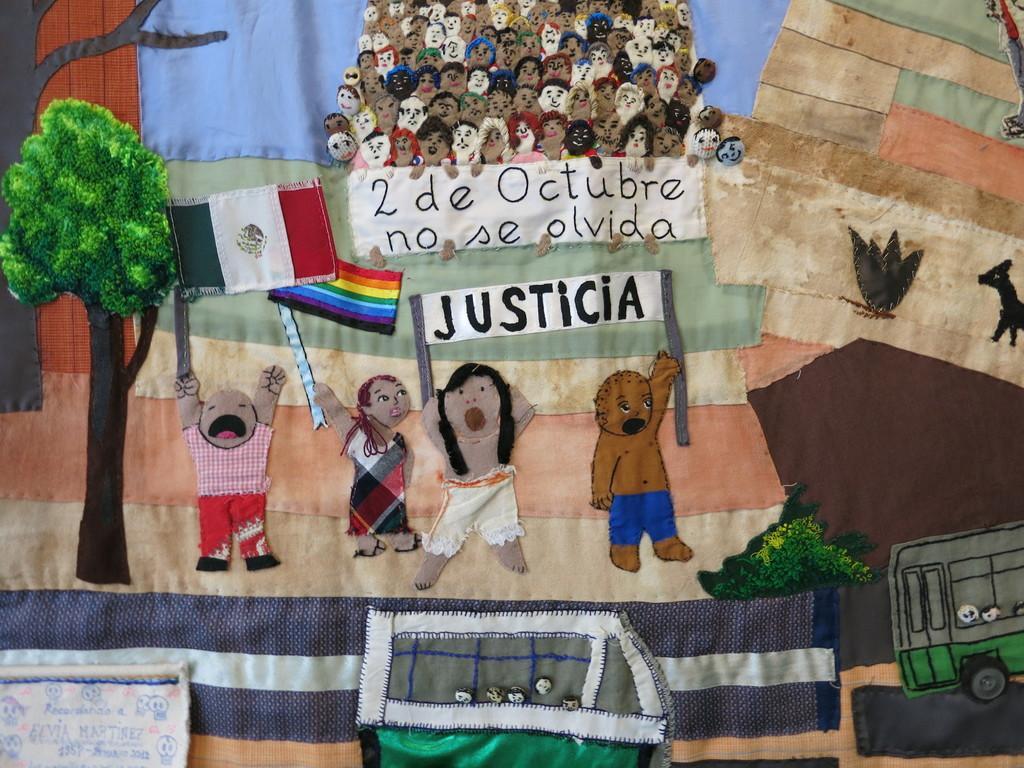Could you give a brief overview of what you see in this image? In this image I can see the colorful cloth in which I can see few pictures of people, trees, flags, boards, an animal and the vehicles. 